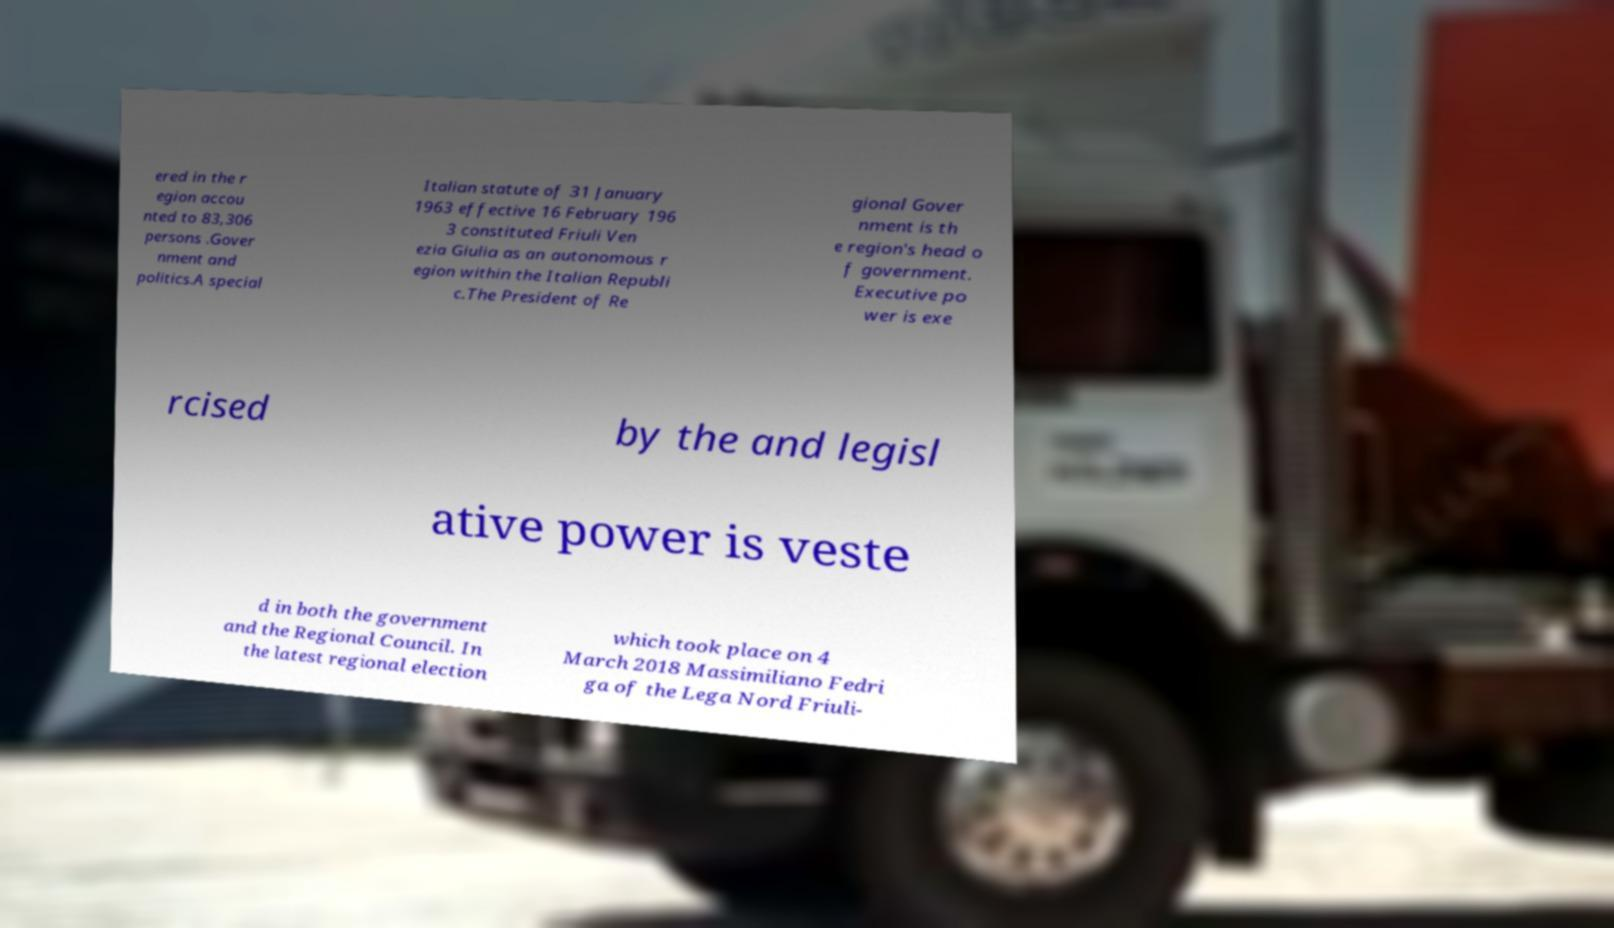Can you accurately transcribe the text from the provided image for me? ered in the r egion accou nted to 83,306 persons .Gover nment and politics.A special Italian statute of 31 January 1963 effective 16 February 196 3 constituted Friuli Ven ezia Giulia as an autonomous r egion within the Italian Republi c.The President of Re gional Gover nment is th e region's head o f government. Executive po wer is exe rcised by the and legisl ative power is veste d in both the government and the Regional Council. In the latest regional election which took place on 4 March 2018 Massimiliano Fedri ga of the Lega Nord Friuli- 